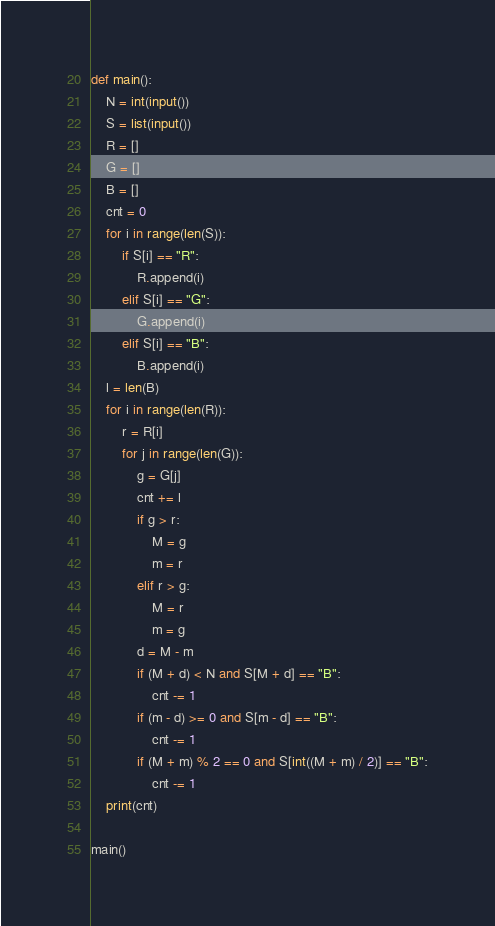Convert code to text. <code><loc_0><loc_0><loc_500><loc_500><_Python_>def main():
	N = int(input())
	S = list(input())
	R = []
	G = []
	B = []
	cnt = 0
	for i in range(len(S)):
		if S[i] == "R":
			R.append(i)
		elif S[i] == "G":
			G.append(i)
		elif S[i] == "B":
			B.append(i)
	l = len(B)
	for i in range(len(R)):
		r = R[i]
		for j in range(len(G)):
			g = G[j]
			cnt += l
			if g > r:
				M = g
				m = r
			elif r > g:
				M = r
				m = g
			d = M - m
			if (M + d) < N and S[M + d] == "B":
				cnt -= 1
			if (m - d) >= 0 and S[m - d] == "B":
				cnt -= 1
			if (M + m) % 2 == 0 and S[int((M + m) / 2)] == "B":
				cnt -= 1
	print(cnt)

main()</code> 